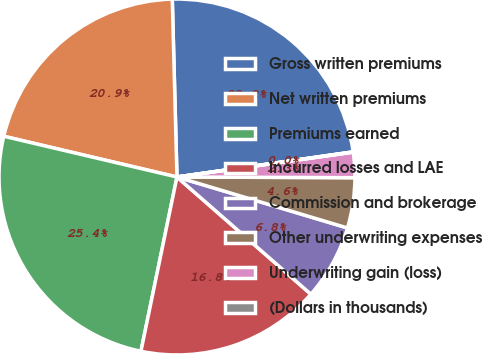Convert chart to OTSL. <chart><loc_0><loc_0><loc_500><loc_500><pie_chart><fcel>Gross written premiums<fcel>Net written premiums<fcel>Premiums earned<fcel>Incurred losses and LAE<fcel>Commission and brokerage<fcel>Other underwriting expenses<fcel>Underwriting gain (loss)<fcel>(Dollars in thousands)<nl><fcel>23.16%<fcel>20.9%<fcel>25.43%<fcel>16.8%<fcel>6.82%<fcel>4.56%<fcel>2.29%<fcel>0.03%<nl></chart> 